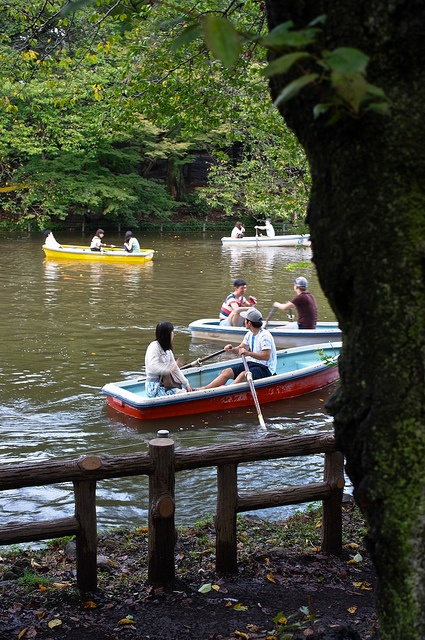Describe the objects in this image and their specific colors. I can see boat in darkgray, maroon, white, and black tones, people in darkgray, lavender, black, gray, and brown tones, people in darkgray, lightgray, black, and gray tones, boat in darkgray, white, and gray tones, and boat in darkgray, gold, white, and tan tones in this image. 